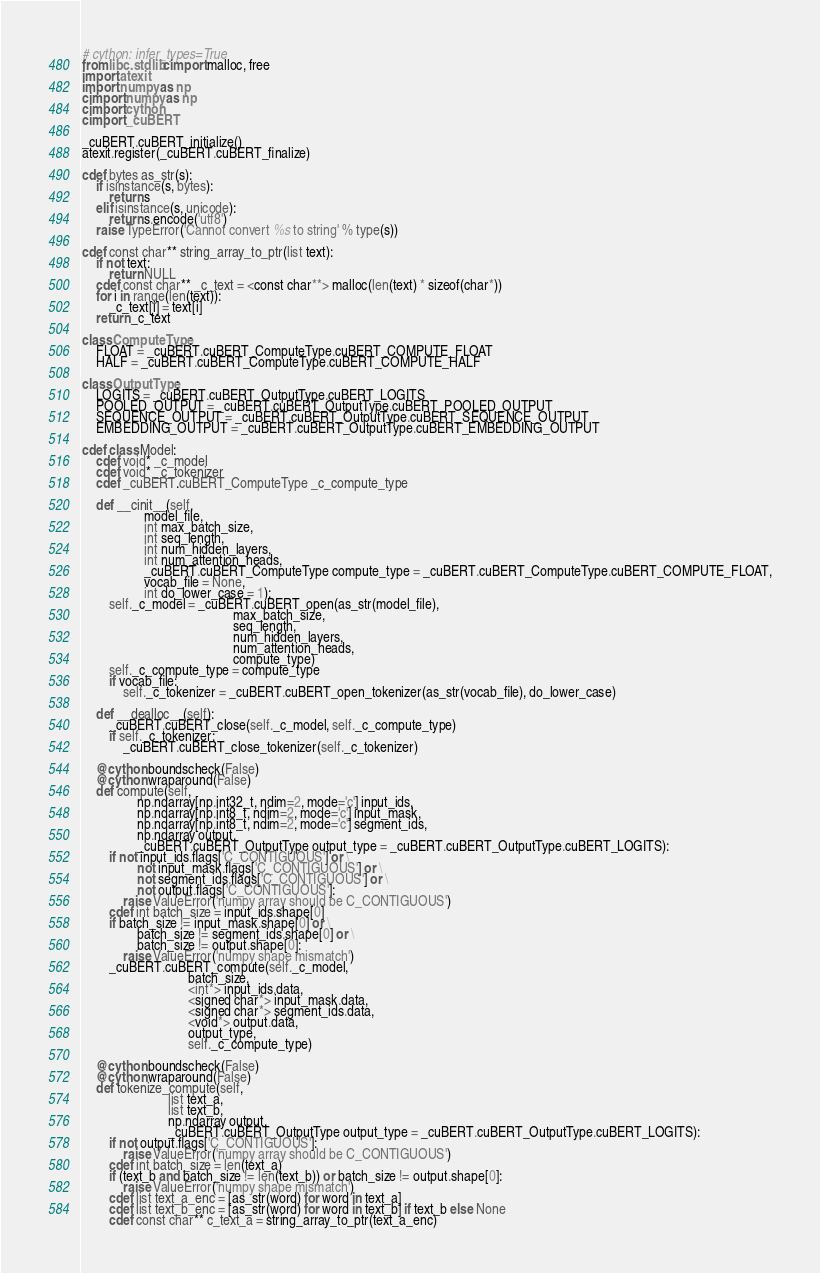Convert code to text. <code><loc_0><loc_0><loc_500><loc_500><_Cython_># cython: infer_types=True
from libc.stdlib cimport malloc, free
import atexit
import numpy as np
cimport numpy as np
cimport cython
cimport _cuBERT

_cuBERT.cuBERT_initialize()
atexit.register(_cuBERT.cuBERT_finalize)

cdef bytes as_str(s):
    if isinstance(s, bytes):
        return s
    elif isinstance(s, unicode):
        return s.encode('utf8')
    raise TypeError('Cannot convert %s to string' % type(s))

cdef const char** string_array_to_ptr(list text):
    if not text:
        return NULL
    cdef const char** _c_text = <const char**> malloc(len(text) * sizeof(char*))
    for i in range(len(text)):
        _c_text[i] = text[i]
    return _c_text

class ComputeType:
    FLOAT = _cuBERT.cuBERT_ComputeType.cuBERT_COMPUTE_FLOAT
    HALF = _cuBERT.cuBERT_ComputeType.cuBERT_COMPUTE_HALF

class OutputType:
    LOGITS = _cuBERT.cuBERT_OutputType.cuBERT_LOGITS
    POOLED_OUTPUT = _cuBERT.cuBERT_OutputType.cuBERT_POOLED_OUTPUT
    SEQUENCE_OUTPUT = _cuBERT.cuBERT_OutputType.cuBERT_SEQUENCE_OUTPUT
    EMBEDDING_OUTPUT = _cuBERT.cuBERT_OutputType.cuBERT_EMBEDDING_OUTPUT

cdef class Model:
    cdef void* _c_model
    cdef void* _c_tokenizer
    cdef _cuBERT.cuBERT_ComputeType _c_compute_type

    def __cinit__(self, 
                  model_file,
                  int max_batch_size,
                  int seq_length,
                  int num_hidden_layers,
                  int num_attention_heads,
                  _cuBERT.cuBERT_ComputeType compute_type = _cuBERT.cuBERT_ComputeType.cuBERT_COMPUTE_FLOAT,
                  vocab_file = None,
                  int do_lower_case = 1):
        self._c_model = _cuBERT.cuBERT_open(as_str(model_file), 
                                            max_batch_size,
                                            seq_length,
                                            num_hidden_layers,
                                            num_attention_heads,
                                            compute_type)
        self._c_compute_type = compute_type
        if vocab_file:
            self._c_tokenizer = _cuBERT.cuBERT_open_tokenizer(as_str(vocab_file), do_lower_case)
    
    def __dealloc__(self):
        _cuBERT.cuBERT_close(self._c_model, self._c_compute_type)
        if self._c_tokenizer:
            _cuBERT.cuBERT_close_tokenizer(self._c_tokenizer)
    
    @cython.boundscheck(False)
    @cython.wraparound(False)
    def compute(self, 
                np.ndarray[np.int32_t, ndim=2, mode='c'] input_ids,
                np.ndarray[np.int8_t, ndim=2, mode='c'] input_mask,
                np.ndarray[np.int8_t, ndim=2, mode='c'] segment_ids,
                np.ndarray output,
                _cuBERT.cuBERT_OutputType output_type = _cuBERT.cuBERT_OutputType.cuBERT_LOGITS):
        if not input_ids.flags['C_CONTIGUOUS'] or \
                not input_mask.flags['C_CONTIGUOUS'] or \
                not segment_ids.flags['C_CONTIGUOUS'] or \
                not output.flags['C_CONTIGUOUS']:
            raise ValueError('numpy array should be C_CONTIGUOUS')
        cdef int batch_size = input_ids.shape[0]
        if batch_size != input_mask.shape[0] or \
                batch_size != segment_ids.shape[0] or \
                batch_size != output.shape[0]:
            raise ValueError('numpy shape mismatch')
        _cuBERT.cuBERT_compute(self._c_model,
                               batch_size,
                               <int*> input_ids.data,
                               <signed char*> input_mask.data,
                               <signed char*> segment_ids.data,
                               <void*> output.data,
                               output_type,
                               self._c_compute_type)

    @cython.boundscheck(False)
    @cython.wraparound(False)
    def tokenize_compute(self, 
                         list text_a, 
                         list text_b, 
                         np.ndarray output,
                         _cuBERT.cuBERT_OutputType output_type = _cuBERT.cuBERT_OutputType.cuBERT_LOGITS):
        if not output.flags['C_CONTIGUOUS']:
            raise ValueError('numpy array should be C_CONTIGUOUS')
        cdef int batch_size = len(text_a)
        if (text_b and batch_size != len(text_b)) or batch_size != output.shape[0]:
            raise ValueError('numpy shape mismatch')
        cdef list text_a_enc = [as_str(word) for word in text_a]
        cdef list text_b_enc = [as_str(word) for word in text_b] if text_b else None
        cdef const char** c_text_a = string_array_to_ptr(text_a_enc)  </code> 